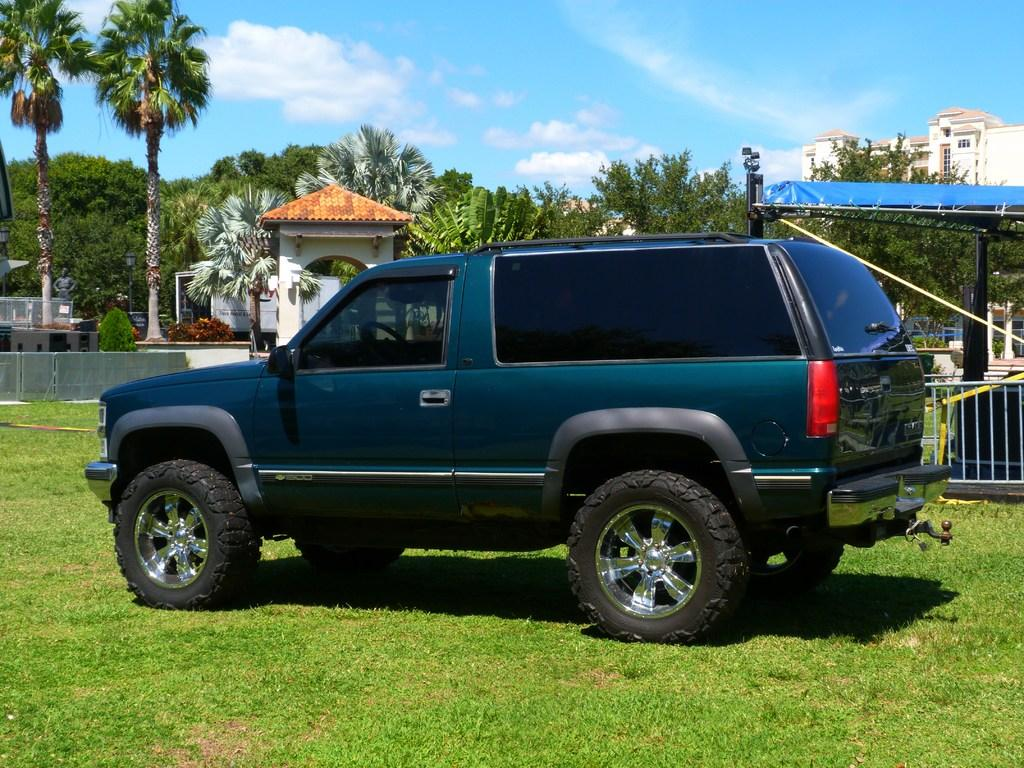What is the main subject in the center of the image? There is a car in the center of the image. What type of natural environment is visible at the bottom of the image? There is grass at the bottom of the image. What can be seen in the background of the image? There are trees, a statue, a tent, plants, a building, the sky, and clouds visible in the background of the image. What type of underwear is hanging on the statue in the background of the image? There is no underwear present in the image, and therefore no such item can be observed on the statue. 